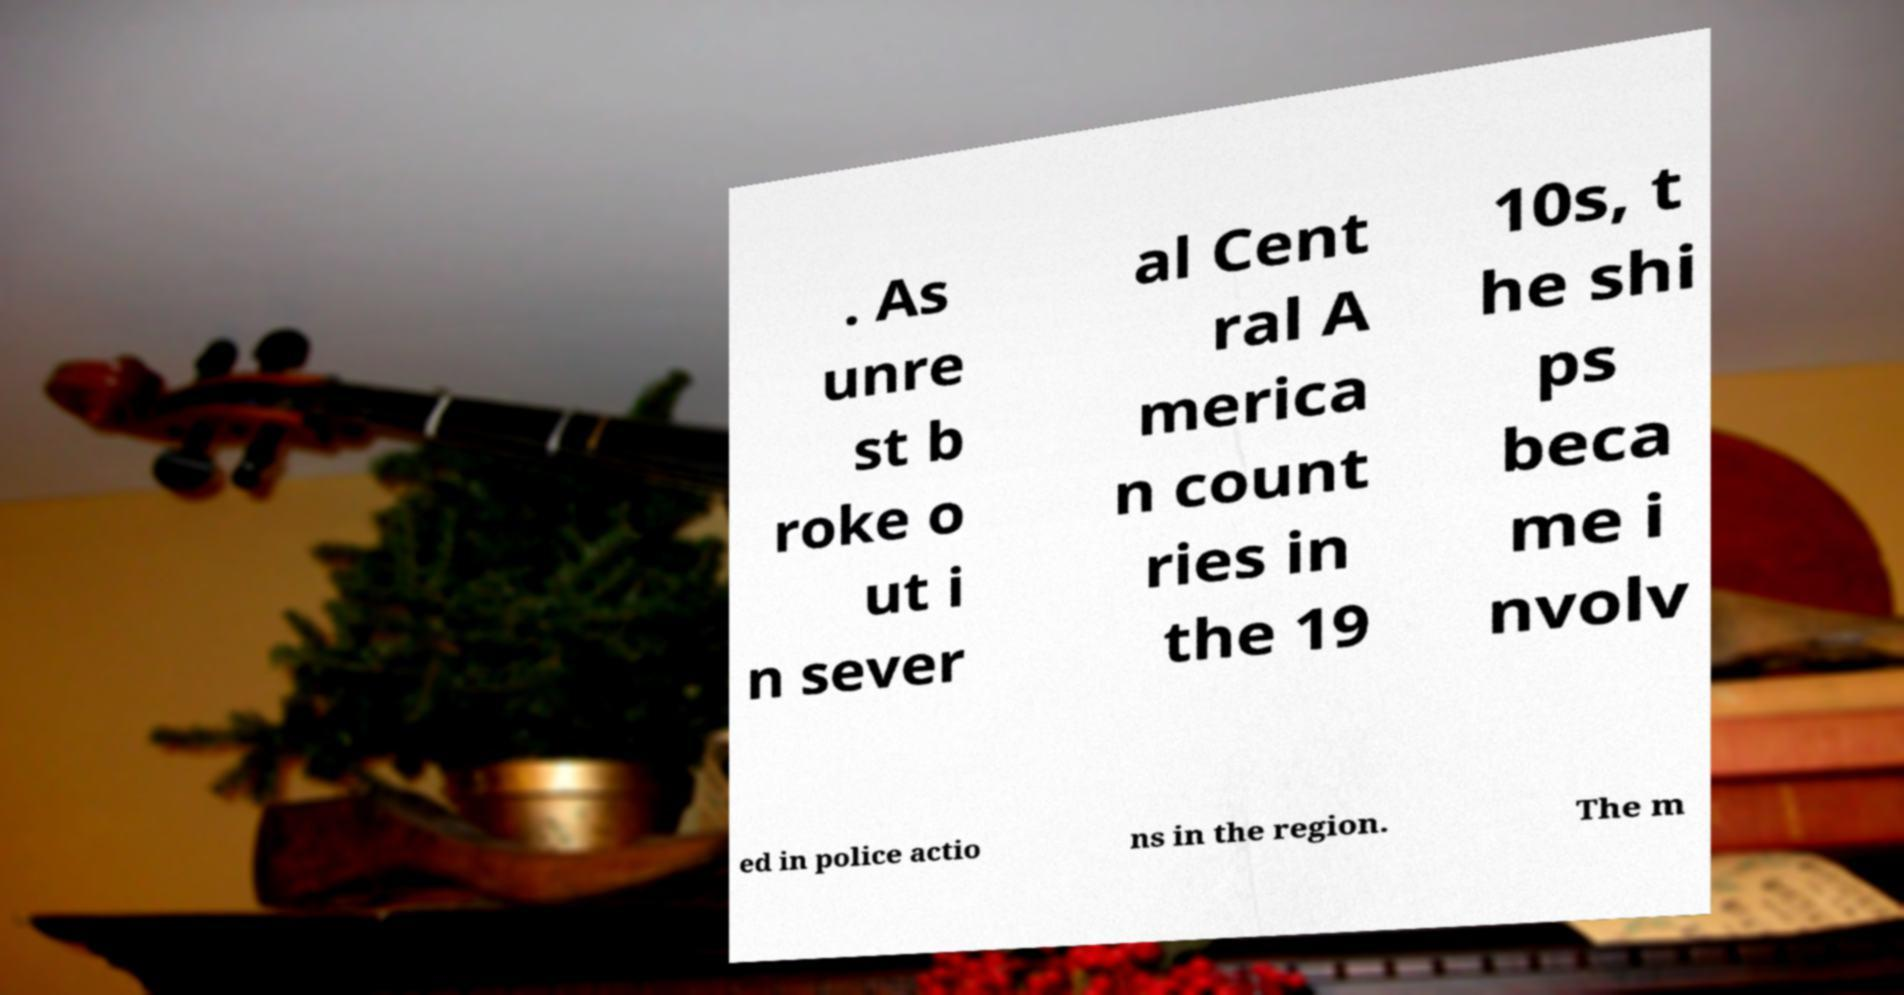Could you assist in decoding the text presented in this image and type it out clearly? . As unre st b roke o ut i n sever al Cent ral A merica n count ries in the 19 10s, t he shi ps beca me i nvolv ed in police actio ns in the region. The m 